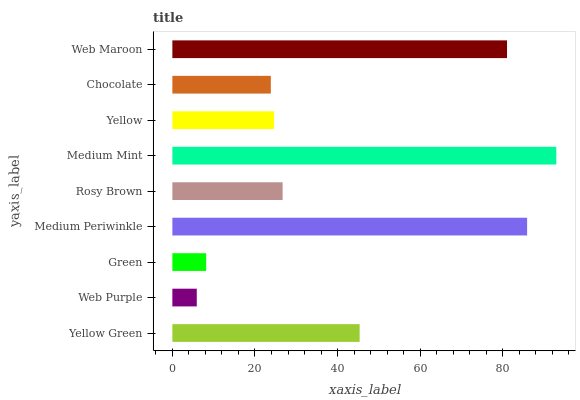Is Web Purple the minimum?
Answer yes or no. Yes. Is Medium Mint the maximum?
Answer yes or no. Yes. Is Green the minimum?
Answer yes or no. No. Is Green the maximum?
Answer yes or no. No. Is Green greater than Web Purple?
Answer yes or no. Yes. Is Web Purple less than Green?
Answer yes or no. Yes. Is Web Purple greater than Green?
Answer yes or no. No. Is Green less than Web Purple?
Answer yes or no. No. Is Rosy Brown the high median?
Answer yes or no. Yes. Is Rosy Brown the low median?
Answer yes or no. Yes. Is Chocolate the high median?
Answer yes or no. No. Is Yellow Green the low median?
Answer yes or no. No. 